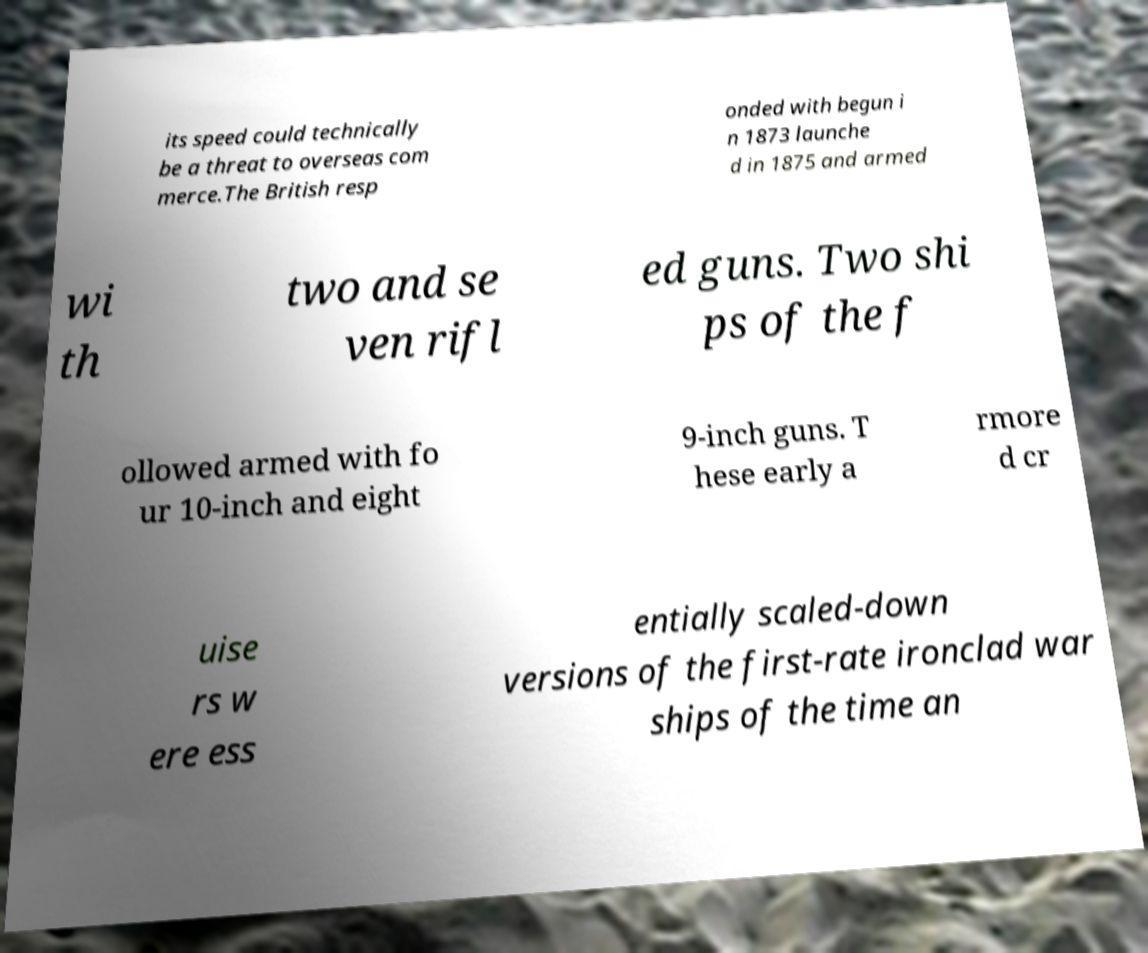Can you accurately transcribe the text from the provided image for me? its speed could technically be a threat to overseas com merce.The British resp onded with begun i n 1873 launche d in 1875 and armed wi th two and se ven rifl ed guns. Two shi ps of the f ollowed armed with fo ur 10-inch and eight 9-inch guns. T hese early a rmore d cr uise rs w ere ess entially scaled-down versions of the first-rate ironclad war ships of the time an 